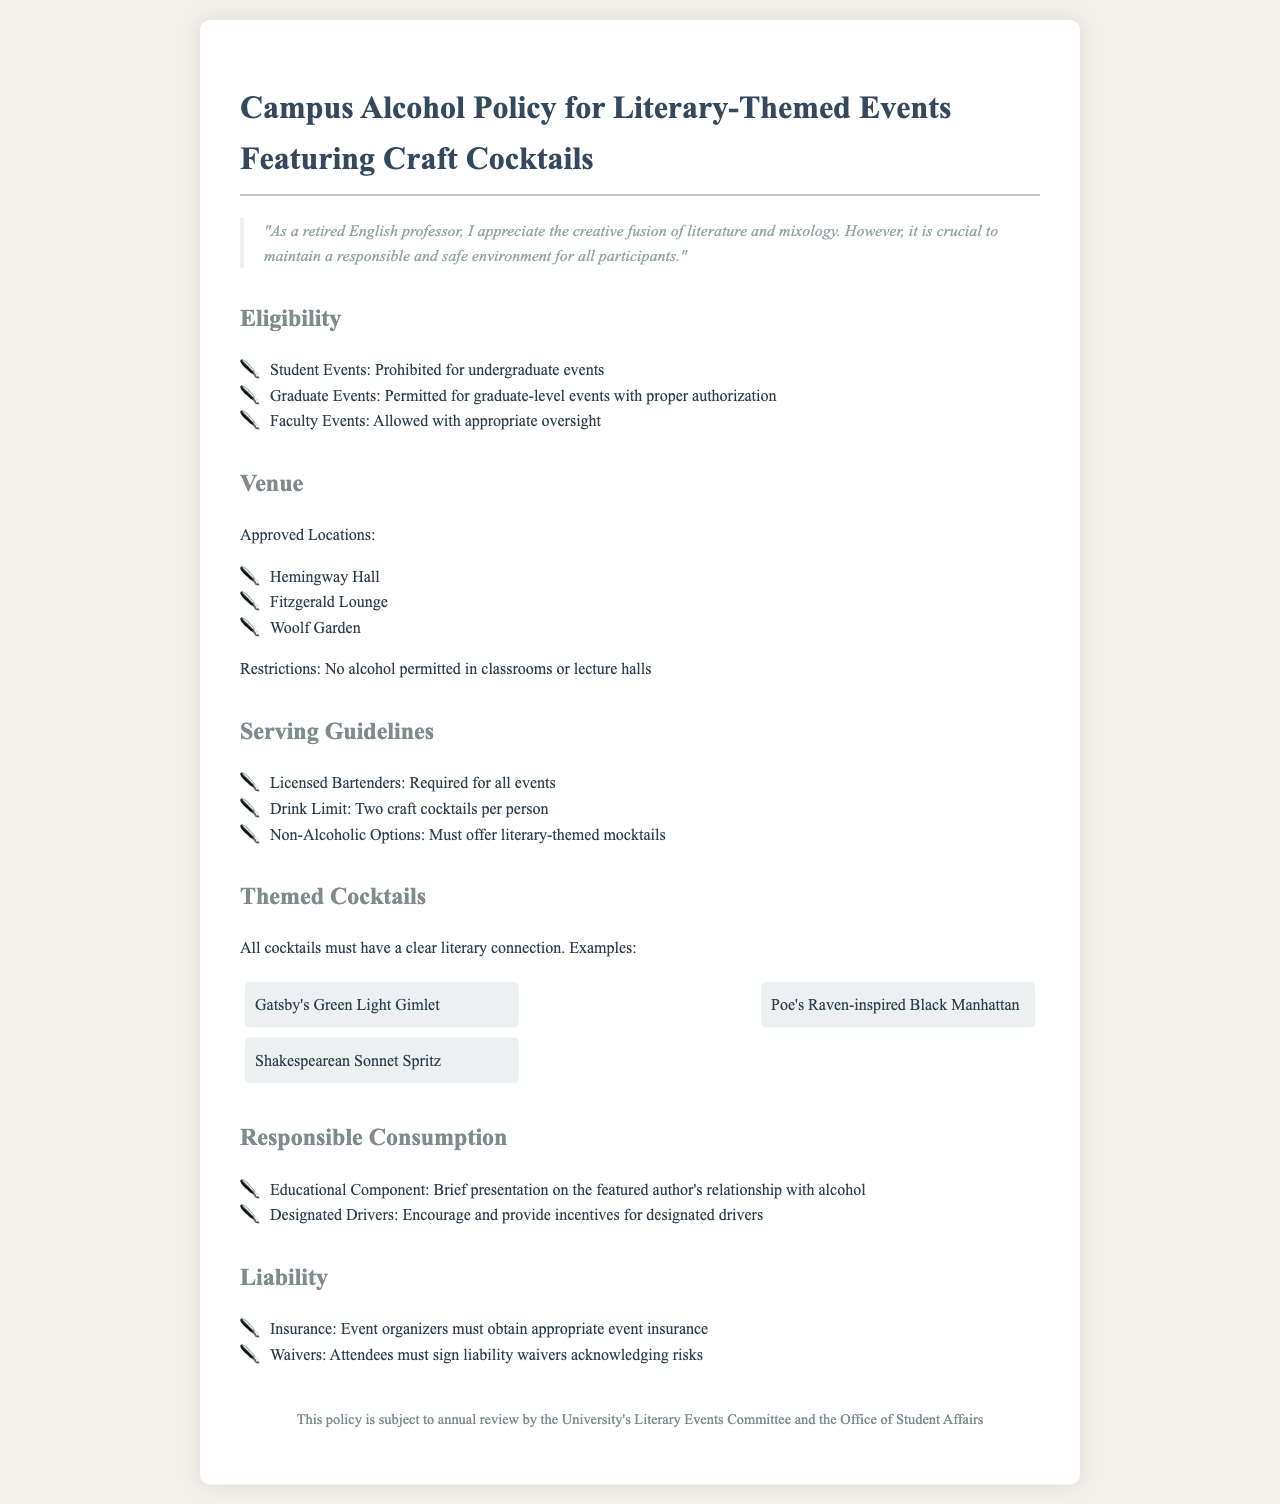what types of events are prohibited for alcohol service? The document specifies that undergraduate events are prohibited from serving alcohol.
Answer: undergraduate events which locations are approved for alcohol service? The document lists approved locations where alcohol can be served during events.
Answer: Hemingway Hall, Fitzgerald Lounge, Woolf Garden what is the drink limit per person? The guideline specifies a limit on the number of craft cocktails served to each participant.
Answer: Two craft cocktails who is required for all bartending at events? The document states that specific personnel must be present for serving drinks at the events.
Answer: Licensed Bartenders what must attendees sign before participating in events? The policy states that attendees must acknowledge the risks associated with alcohol service.
Answer: liability waivers how many literary-themed mocktails must be offered? The guideline indicates a requirement for non-alcoholic options at events.
Answer: Must offer what is required to be included in the educational component? The document outlines a specific topic that must be covered during events for responsible consumption.
Answer: Author's relationship with alcohol who is responsible for obtaining event insurance? The liability section specifies who must take action regarding insurance for events.
Answer: Event organizers how often is the campus alcohol policy reviewed? The document states the frequency of review for the policy by committees.
Answer: annual review 